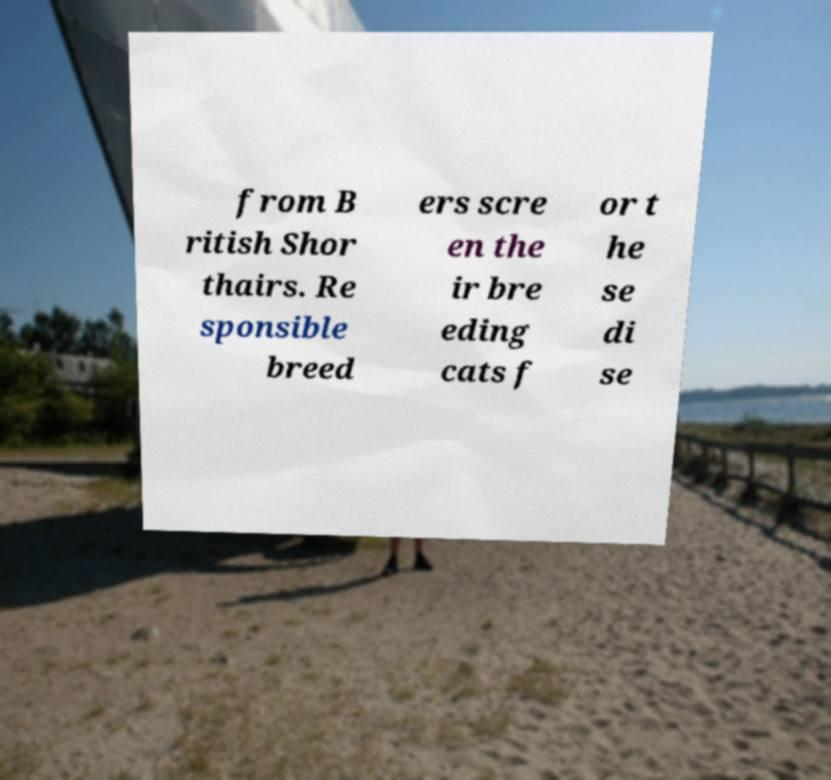I need the written content from this picture converted into text. Can you do that? from B ritish Shor thairs. Re sponsible breed ers scre en the ir bre eding cats f or t he se di se 